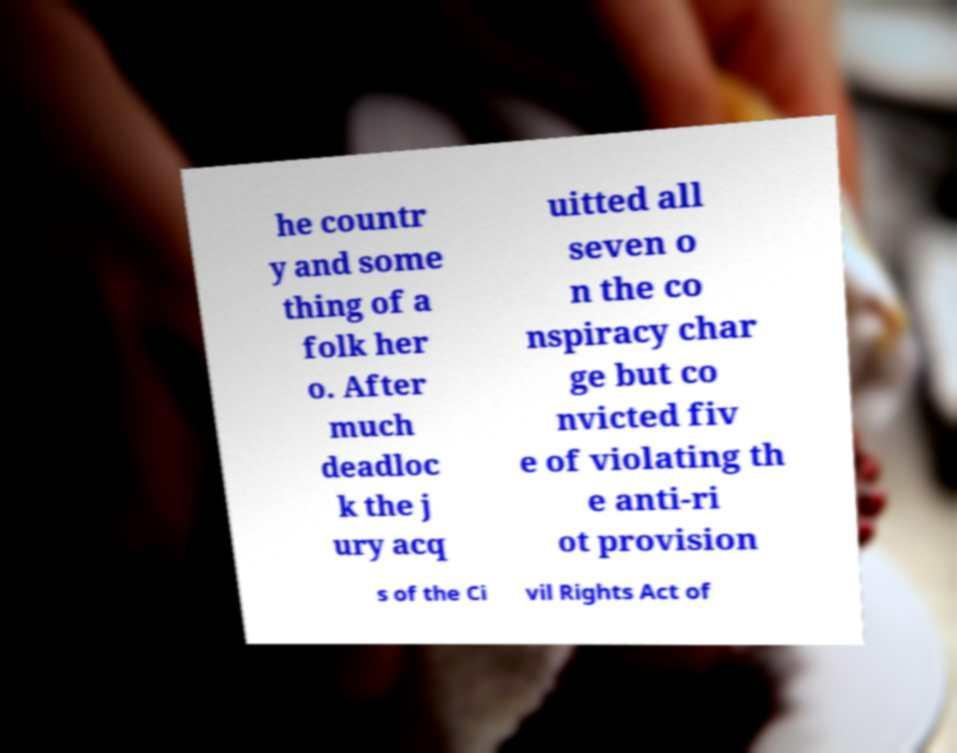For documentation purposes, I need the text within this image transcribed. Could you provide that? he countr y and some thing of a folk her o. After much deadloc k the j ury acq uitted all seven o n the co nspiracy char ge but co nvicted fiv e of violating th e anti-ri ot provision s of the Ci vil Rights Act of 